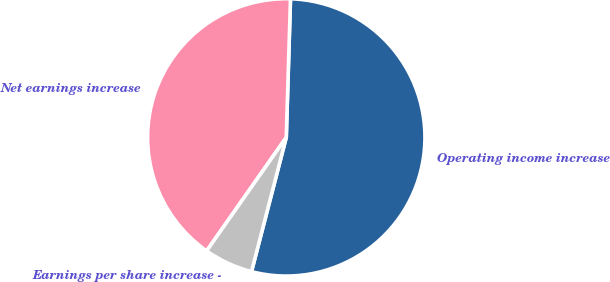Convert chart. <chart><loc_0><loc_0><loc_500><loc_500><pie_chart><fcel>Operating income increase<fcel>Net earnings increase<fcel>Earnings per share increase -<nl><fcel>53.55%<fcel>40.75%<fcel>5.7%<nl></chart> 